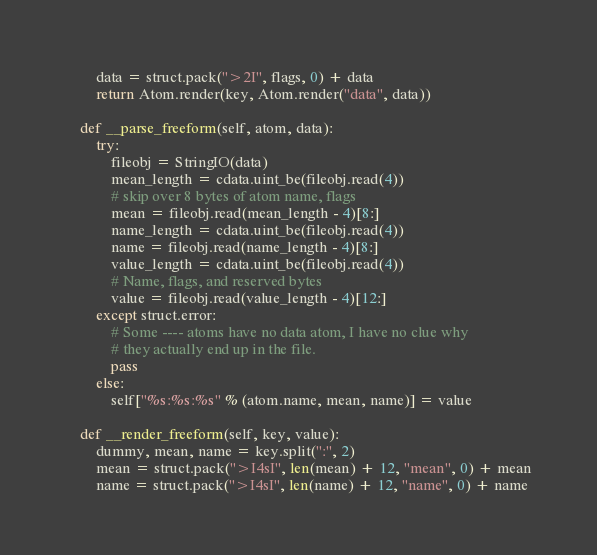Convert code to text. <code><loc_0><loc_0><loc_500><loc_500><_Python_>        data = struct.pack(">2I", flags, 0) + data
        return Atom.render(key, Atom.render("data", data))

    def __parse_freeform(self, atom, data):
        try:
            fileobj = StringIO(data)
            mean_length = cdata.uint_be(fileobj.read(4))
            # skip over 8 bytes of atom name, flags
            mean = fileobj.read(mean_length - 4)[8:]
            name_length = cdata.uint_be(fileobj.read(4))
            name = fileobj.read(name_length - 4)[8:]
            value_length = cdata.uint_be(fileobj.read(4))
            # Name, flags, and reserved bytes
            value = fileobj.read(value_length - 4)[12:]
        except struct.error:
            # Some ---- atoms have no data atom, I have no clue why
            # they actually end up in the file.
            pass
        else:
            self["%s:%s:%s" % (atom.name, mean, name)] = value

    def __render_freeform(self, key, value):
        dummy, mean, name = key.split(":", 2)
        mean = struct.pack(">I4sI", len(mean) + 12, "mean", 0) + mean
        name = struct.pack(">I4sI", len(name) + 12, "name", 0) + name</code> 